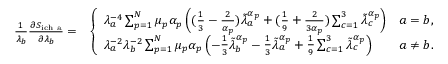Convert formula to latex. <formula><loc_0><loc_0><loc_500><loc_500>\begin{array} { r l } { \frac { 1 } { \lambda _ { b } } \frac { \partial S _ { i c h a } } { \partial \lambda _ { b } } = } & { \left \{ \begin{array} { l l } { \lambda _ { a } ^ { - 4 } \sum _ { p = 1 } ^ { N } \mu _ { p } \alpha _ { p } \left ( ( \frac { 1 } { 3 } - \frac { 2 } { \alpha _ { p } } ) \tilde { \lambda } _ { a } ^ { \alpha _ { p } } + ( \frac { 1 } { 9 } + \frac { 2 } { 3 \alpha _ { p } } ) \sum _ { c = 1 } ^ { 3 } \tilde { \lambda } _ { c } ^ { \alpha _ { p } } \right ) } & { a = b , } \\ { \lambda _ { a } ^ { - 2 } \lambda _ { b } ^ { - 2 } \sum _ { p = 1 } ^ { N } \mu _ { p } \alpha _ { p } \left ( - \frac { 1 } { 3 } \tilde { \lambda } _ { b } ^ { \alpha _ { p } } - \frac { 1 } { 3 } \tilde { \lambda } _ { a } ^ { \alpha _ { p } } + \frac { 1 } { 9 } \sum _ { c = 1 } ^ { 3 } \tilde { \lambda } _ { c } ^ { \alpha _ { p } } \right ) } & { a \neq b . } \end{array} } \end{array}</formula> 